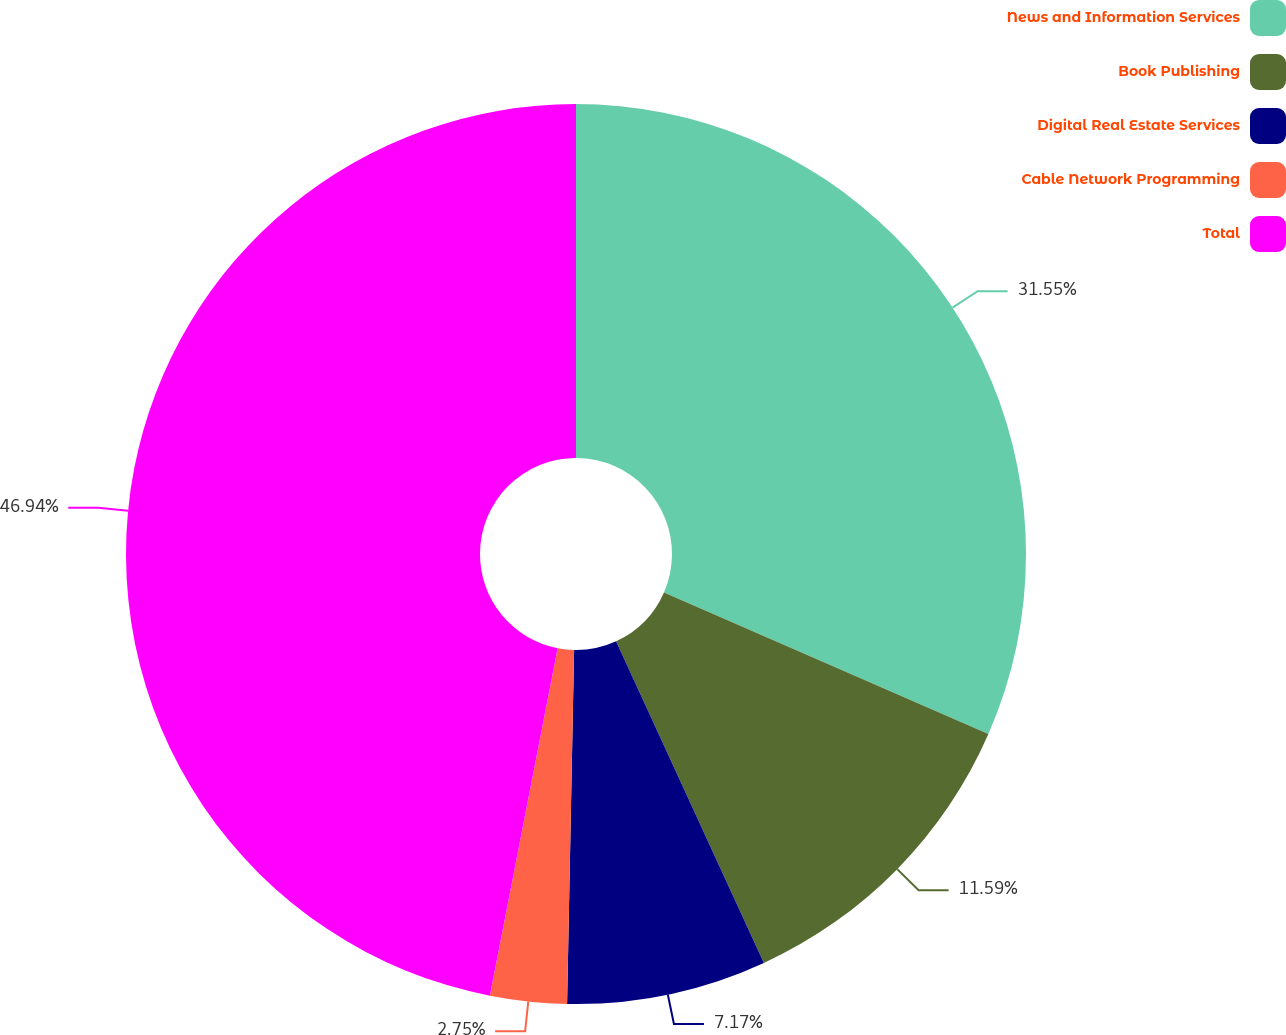<chart> <loc_0><loc_0><loc_500><loc_500><pie_chart><fcel>News and Information Services<fcel>Book Publishing<fcel>Digital Real Estate Services<fcel>Cable Network Programming<fcel>Total<nl><fcel>31.55%<fcel>11.59%<fcel>7.17%<fcel>2.75%<fcel>46.93%<nl></chart> 